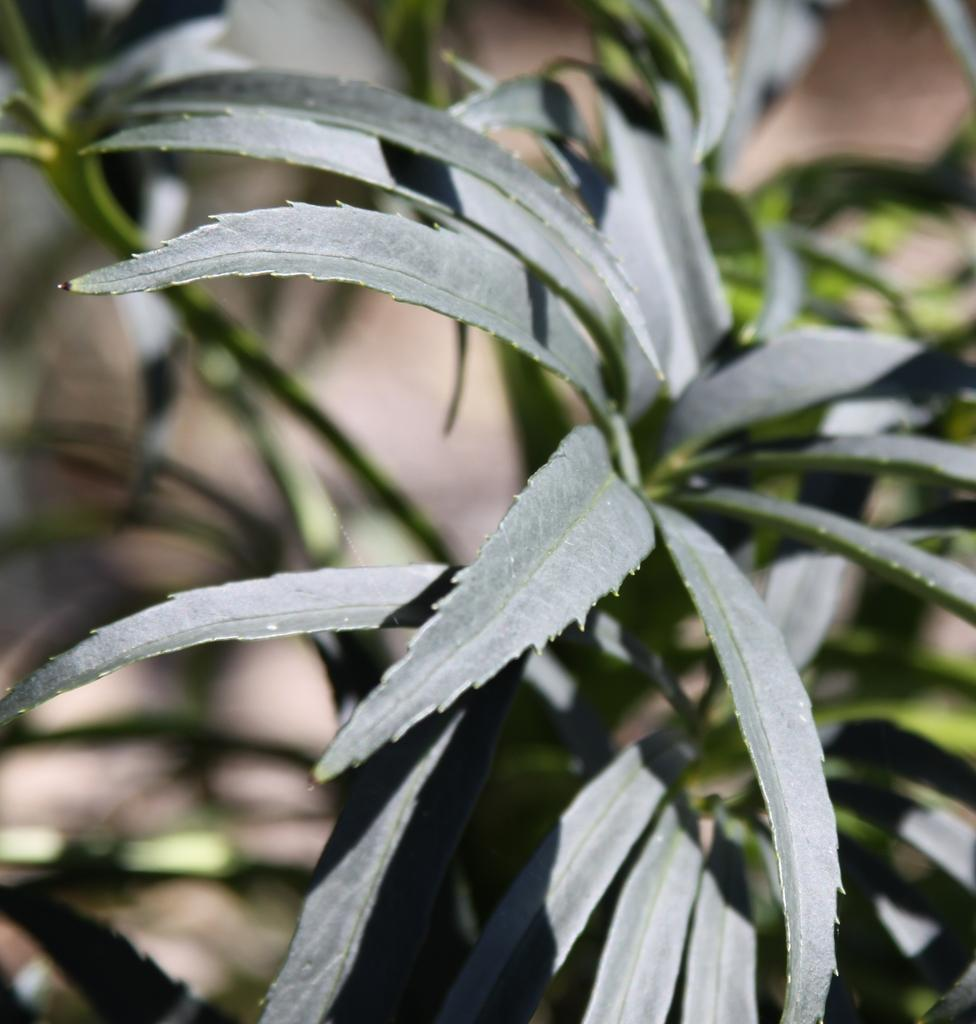What type of vegetation is present on the ground in the image? There are green plants on the ground in the image. Can you describe the background of the image? The background of the image is blurred. What month is it in the image? There is no information about the month in the image. Can you see any rabbits in the image? There are no rabbits present in the image. Is there a harbor visible in the image? There is no harbor present in the image. 